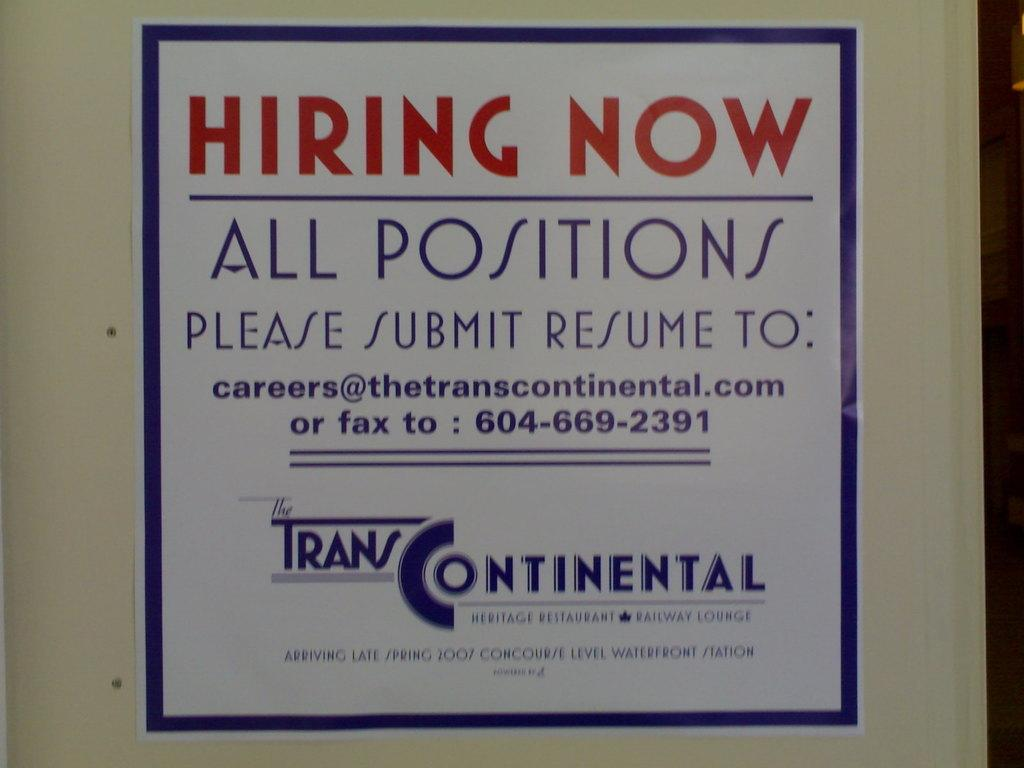What is present on the wall in the picture? There is a poster on the wall in the picture. What can be seen on the poster? There is writing on the poster. What color is the border of the poster? The poster has a blue color border. What is the color of the wall where the poster is placed? The poster is on a white color wall. Can you see a monkey pulling a base in the image? No, there is no monkey or base present in the image. 